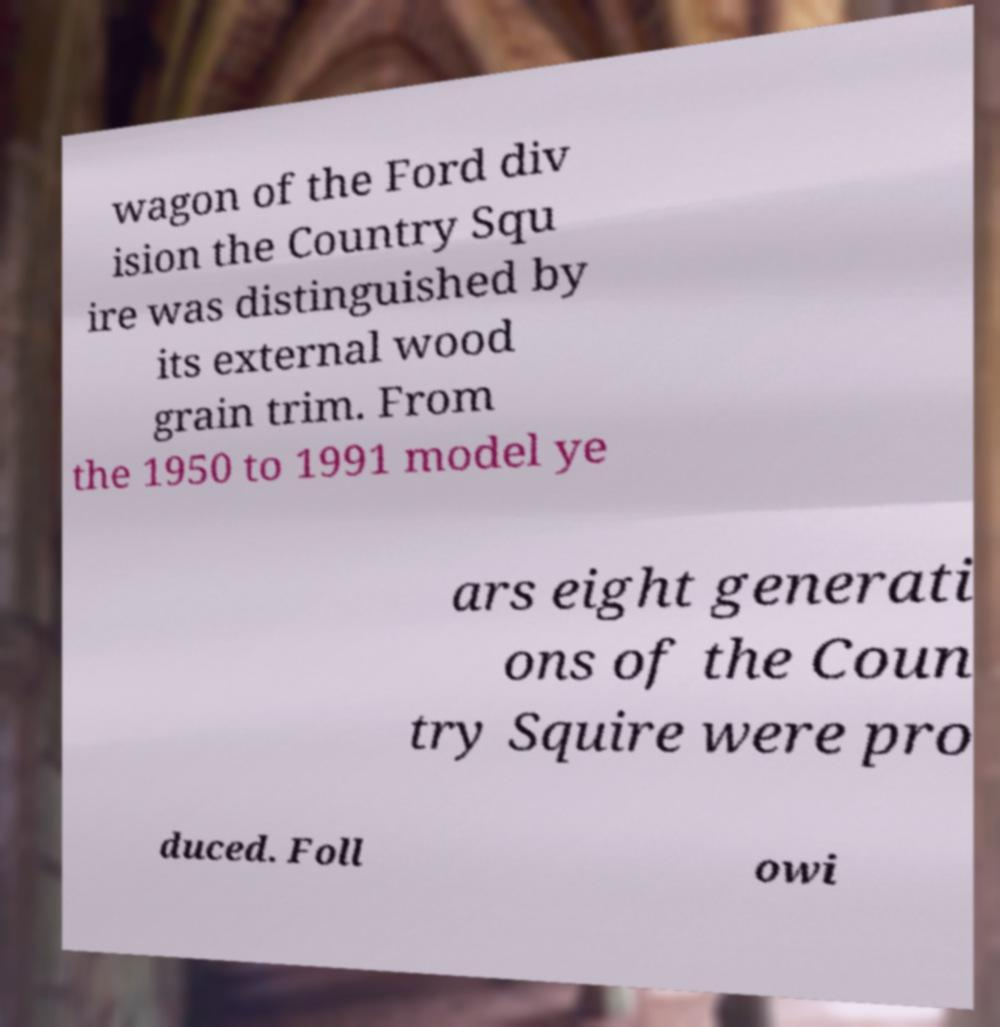There's text embedded in this image that I need extracted. Can you transcribe it verbatim? wagon of the Ford div ision the Country Squ ire was distinguished by its external wood grain trim. From the 1950 to 1991 model ye ars eight generati ons of the Coun try Squire were pro duced. Foll owi 